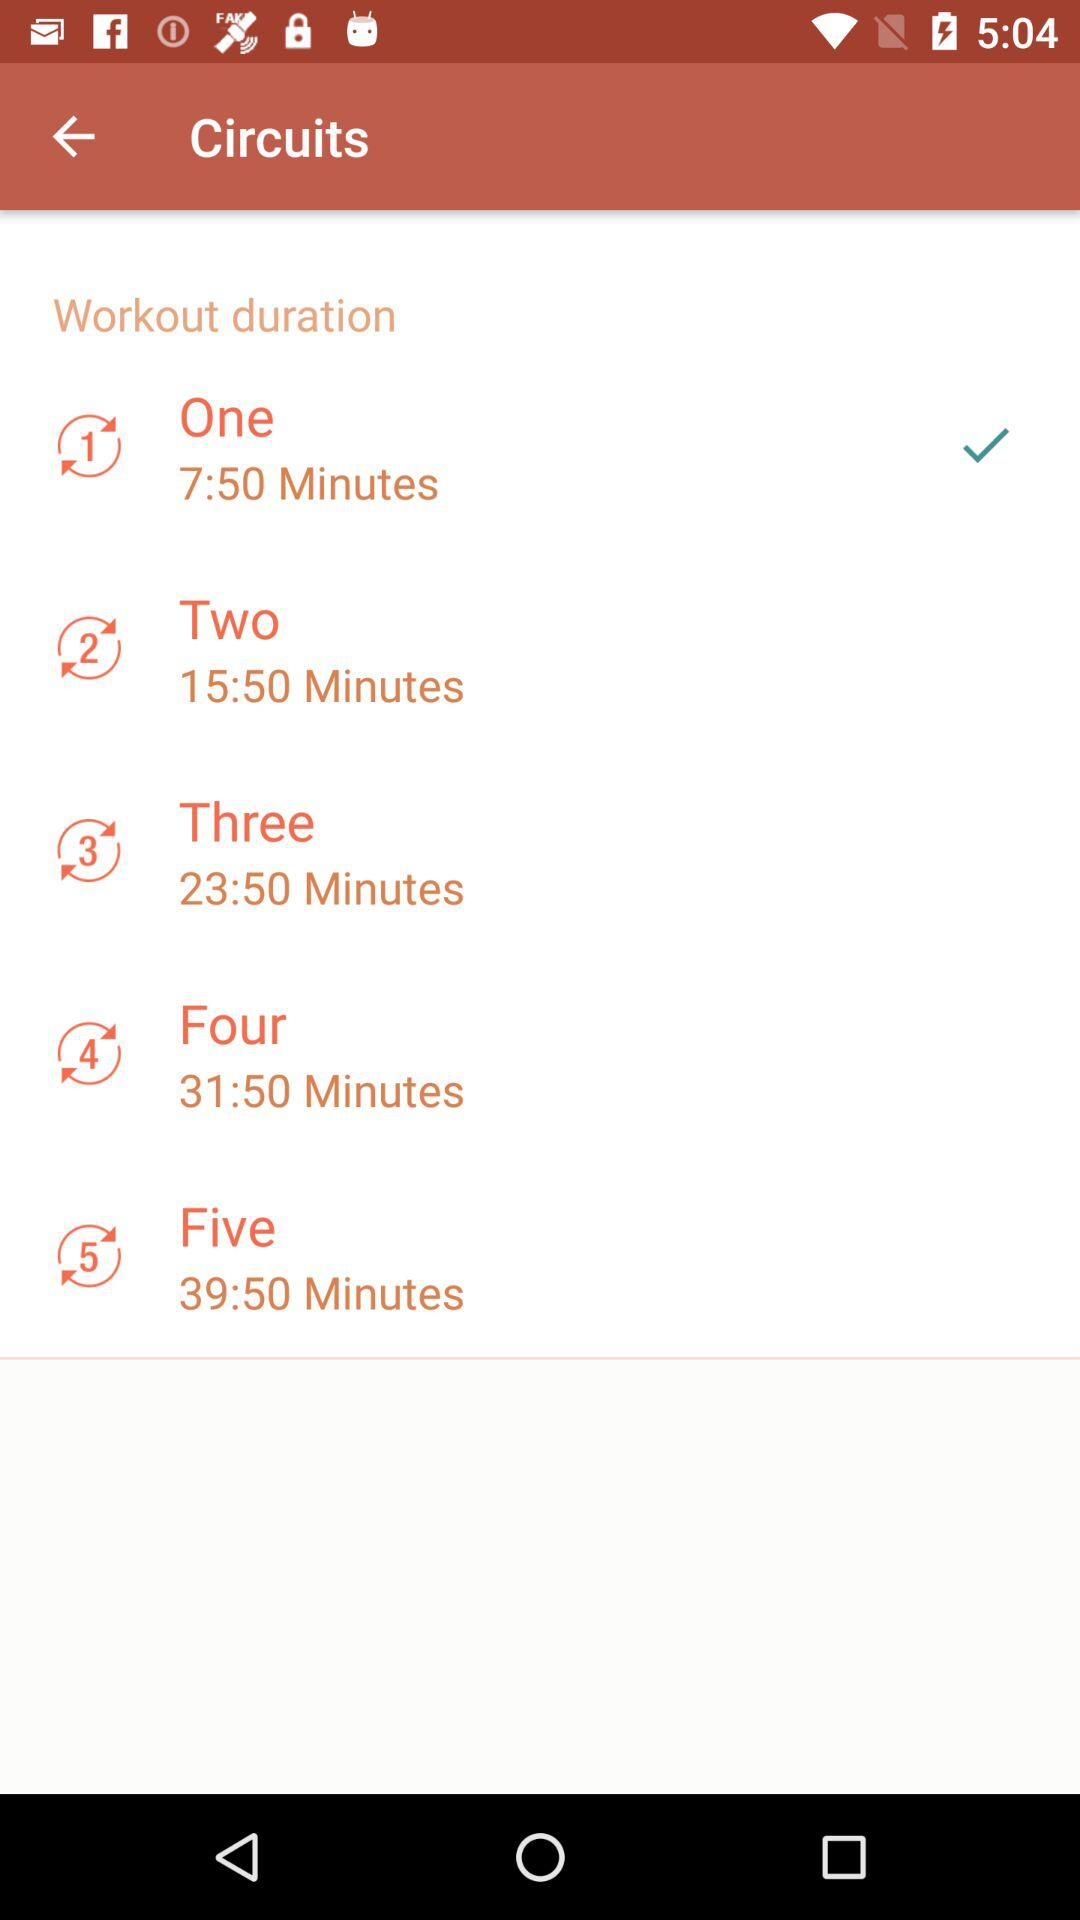What is the workout duration of Circuit 1? The workout duration of Circuit 1 is 7:50 minutes. 